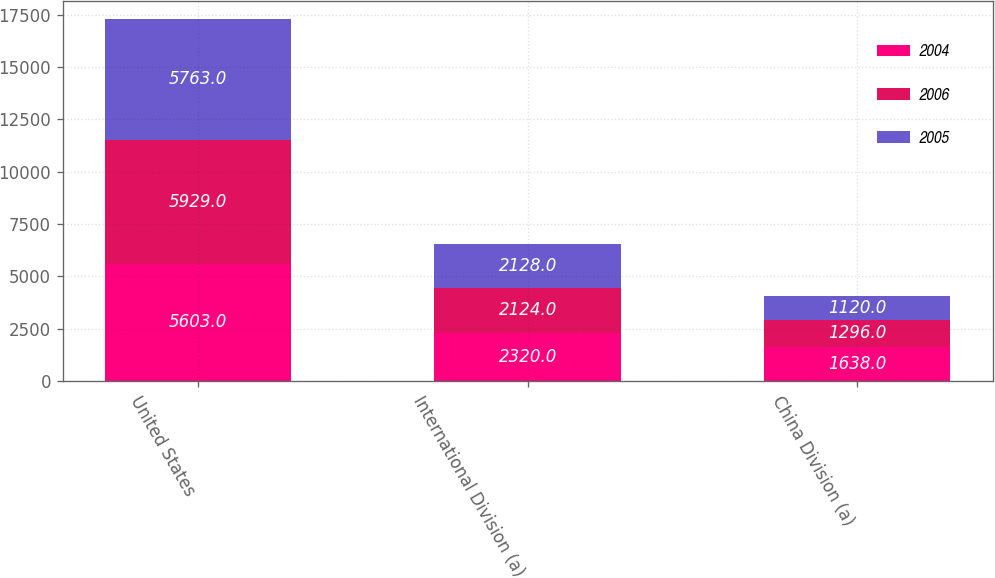Convert chart. <chart><loc_0><loc_0><loc_500><loc_500><stacked_bar_chart><ecel><fcel>United States<fcel>International Division (a)<fcel>China Division (a)<nl><fcel>2004<fcel>5603<fcel>2320<fcel>1638<nl><fcel>2006<fcel>5929<fcel>2124<fcel>1296<nl><fcel>2005<fcel>5763<fcel>2128<fcel>1120<nl></chart> 